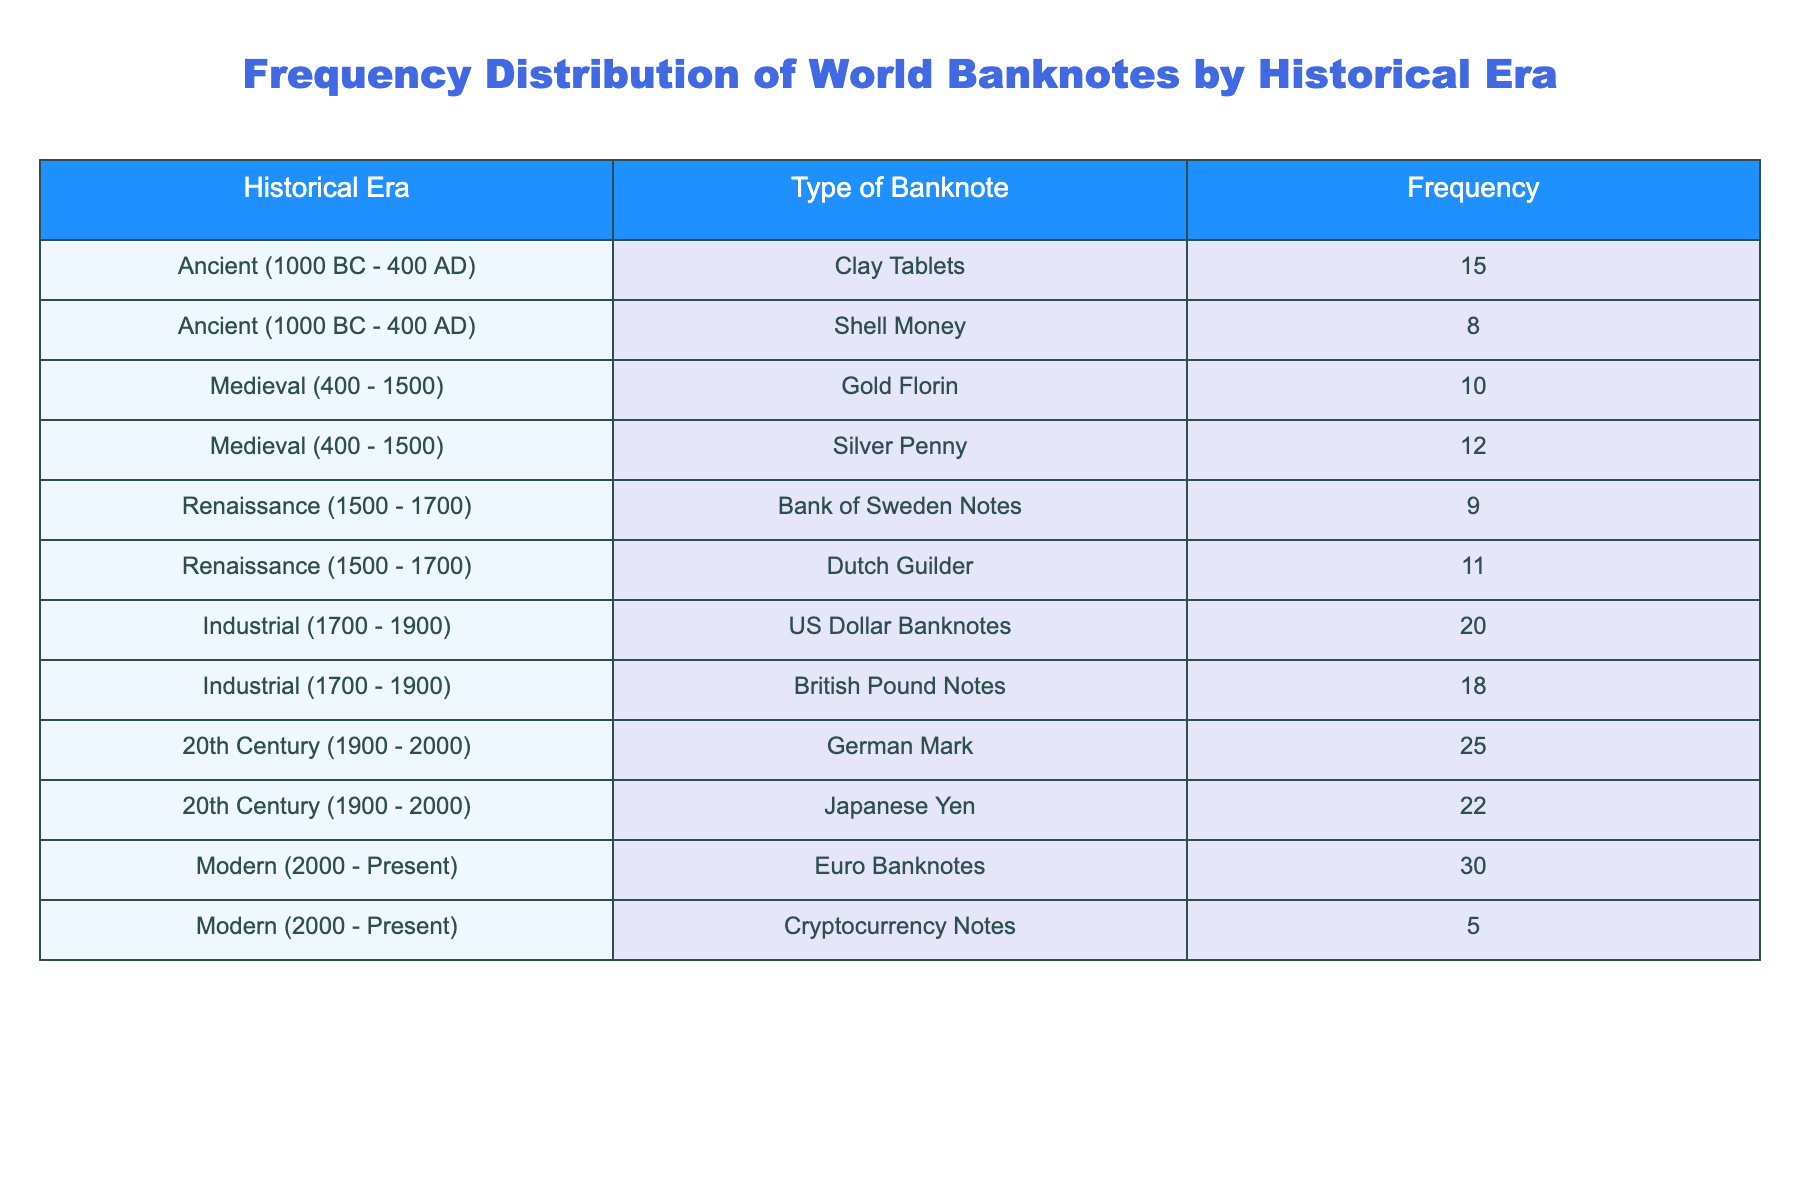What type of banknote has the highest frequency in the 20th Century? The 20th Century row lists two banknotes: the German Mark with a frequency of 25 and the Japanese Yen with a frequency of 22. Since 25 is higher than 22, the German Mark is the one with the highest frequency.
Answer: German Mark How many types of banknotes are collected from the Ancient Era? The Ancient Era consists of two types of banknotes: Clay Tablets and Shell Money, which are the only banknotes listed under this era. Therefore, there are a total of 2 types.
Answer: 2 Which historical era has the least frequency of banknotes collected? The table shows the frequencies of various eras: Ancient (23 total), Medieval (22 total), Renaissance (20 total), Industrial (38 total), 20th Century (47 total), and Modern (35 total). The Medieval era has the lowest total frequency of 22.
Answer: Medieval What is the total frequency of banknotes from the Industrial Era? The Industrial Era includes US Dollar Banknotes (20) and British Pound Notes (18). To find the total, we add the two values: 20 + 18 = 38.
Answer: 38 Is the frequency of the Euro Banknotes greater than the frequency of the British Pound Notes? The frequency of Euro Banknotes is 30, while that of the British Pound Notes is 18. Since 30 is greater than 18, the statement is true.
Answer: Yes What is the average frequency of banknotes from the Renaissance Era? There are 2 banknotes listed in the Renaissance Era: Bank of Sweden Notes (9) and Dutch Guilder (11). To find the average, we sum the frequencies: 9 + 11 = 20, and then divide by the number of banknotes: 20/2 = 10.
Answer: 10 How many banknotes from the Modern Era have a frequency of less than 10? The Modern Era includes Euro Banknotes (30) and Cryptocurrency Notes (5). Out of these, only the Cryptocurrency Notes have a frequency of less than 10. Thus, only 1 banknote meets the criteria.
Answer: 1 If we combine the frequencies from the Ancient and Medieval Eras, what is the total? Under the Ancient Era, the total frequency is 23 (15 for Clay Tablets and 8 for Shell Money) and for the Medieval Era, it is 22 (10 for Gold Florin and 12 for Silver Penny). The total frequency combining both eras is 23 + 22 = 45.
Answer: 45 Which banknote type from the Modern Era has the lowest frequency? The Modern Era contains Euro Banknotes (30) and Cryptocurrency Notes (5). The frequency of the Cryptocurrency Notes (5) is lower than that of the Euro Banknotes.
Answer: Cryptocurrency Notes 